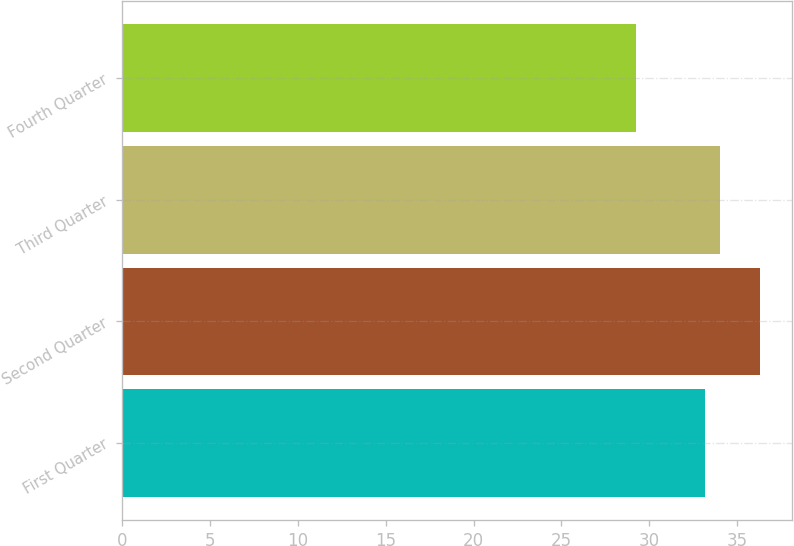Convert chart to OTSL. <chart><loc_0><loc_0><loc_500><loc_500><bar_chart><fcel>First Quarter<fcel>Second Quarter<fcel>Third Quarter<fcel>Fourth Quarter<nl><fcel>33.18<fcel>36.29<fcel>34.02<fcel>29.23<nl></chart> 